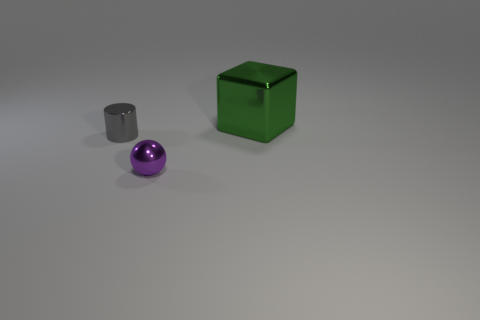There is a thing to the right of the purple metallic object; what is its material?
Your answer should be very brief. Metal. Does the tiny gray thing have the same shape as the small object that is in front of the tiny gray thing?
Make the answer very short. No. Are there more green metallic cubes than small metal objects?
Provide a short and direct response. No. Is there anything else that is the same color as the tiny shiny ball?
Make the answer very short. No. What is the shape of the green thing that is the same material as the small ball?
Ensure brevity in your answer.  Cube. What is the material of the object to the right of the tiny thing in front of the small gray metallic thing?
Your answer should be very brief. Metal. Do the thing to the left of the tiny sphere and the small purple object have the same shape?
Make the answer very short. No. Are there more tiny metal objects behind the big green object than small metallic cylinders?
Keep it short and to the point. No. Is there any other thing that has the same material as the small ball?
Your answer should be compact. Yes. What number of blocks are large things or purple things?
Provide a short and direct response. 1. 